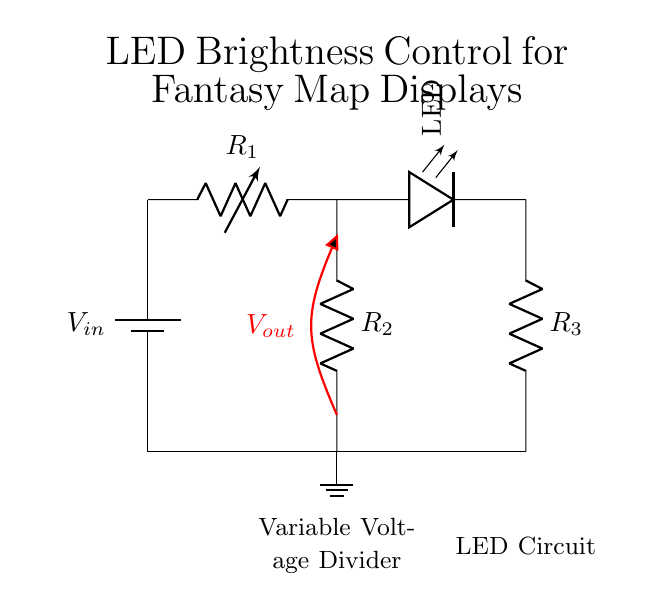What is the purpose of the variable resistor in this circuit? The variable resistor, labeled R1, is used to adjust the voltage output (Vout) which controls the brightness of the LED. By changing its resistance, it alters the distribution of voltage in the circuit.
Answer: Adjust LED brightness What component is used to indicate the current flow? The LED serves as an indicator of current flow. When current passes through it, the LED illuminates, showing that the circuit is active.
Answer: LED What is the output voltage position in the circuit? The output voltage (Vout) is taken from the middle point of the voltage divider, which is between R1 and R2. This position measures the voltage available for the LED directly.
Answer: Between R1 and R2 How many resistors are there in total in this circuit? There are three resistors total: one variable resistor (R1) and two fixed resistors (R2 and R3).
Answer: Three resistors Which component is connected to ground? The ground connection is made at the bottom of both R2 and the LED circuit, which completes the return path for the current in the circuit.
Answer: R2 and LED ground What is the function of resistor R3 in this circuit? Resistor R3 limits the current through the LED, ensuring that it operates safely without drawing too much current, which could damage it.
Answer: Current limit 